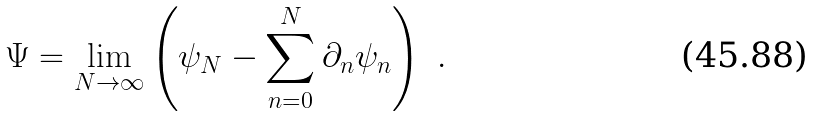Convert formula to latex. <formula><loc_0><loc_0><loc_500><loc_500>\Psi = \lim _ { N \to \infty } \left ( \psi _ { N } - \sum _ { n = 0 } ^ { N } \partial _ { n } \psi _ { n } \right ) \ .</formula> 